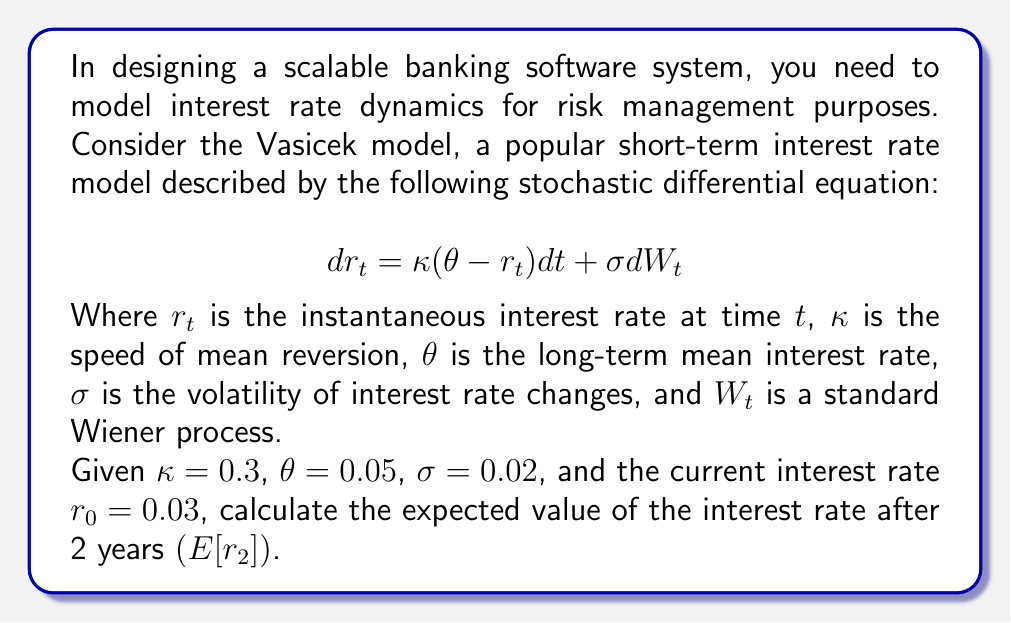Can you solve this math problem? To solve this problem, we need to understand the properties of the Vasicek model and how to calculate the expected value of the interest rate at a future time.

1. The Vasicek model is mean-reverting, which means that the interest rate tends to move towards the long-term mean $\theta$ over time.

2. For the Vasicek model, the expected value of the interest rate at time $t$, given the initial rate $r_0$, is:

   $$ E[r_t] = r_0 e^{-\kappa t} + \theta (1 - e^{-\kappa t}) $$

3. Let's substitute the given values into this formula:
   - $r_0 = 0.03$ (initial interest rate)
   - $\kappa = 0.3$ (speed of mean reversion)
   - $\theta = 0.05$ (long-term mean interest rate)
   - $t = 2$ (time in years)

4. Now, let's calculate step by step:

   $E[r_2] = 0.03 e^{-0.3 \cdot 2} + 0.05 (1 - e^{-0.3 \cdot 2})$

5. First, calculate $e^{-0.3 \cdot 2}$:
   $e^{-0.6} \approx 0.5488$

6. Now, substitute this value:

   $E[r_2] = 0.03 \cdot 0.5488 + 0.05 (1 - 0.5488)$

7. Calculate each term:
   - $0.03 \cdot 0.5488 = 0.016464$
   - $0.05 (1 - 0.5488) = 0.022560$

8. Sum the terms:
   $E[r_2] = 0.016464 + 0.022560 = 0.039024$

Therefore, the expected value of the interest rate after 2 years is approximately 0.039024 or 3.9024%.
Answer: $E[r_2] \approx 0.039024$ or 3.9024% 